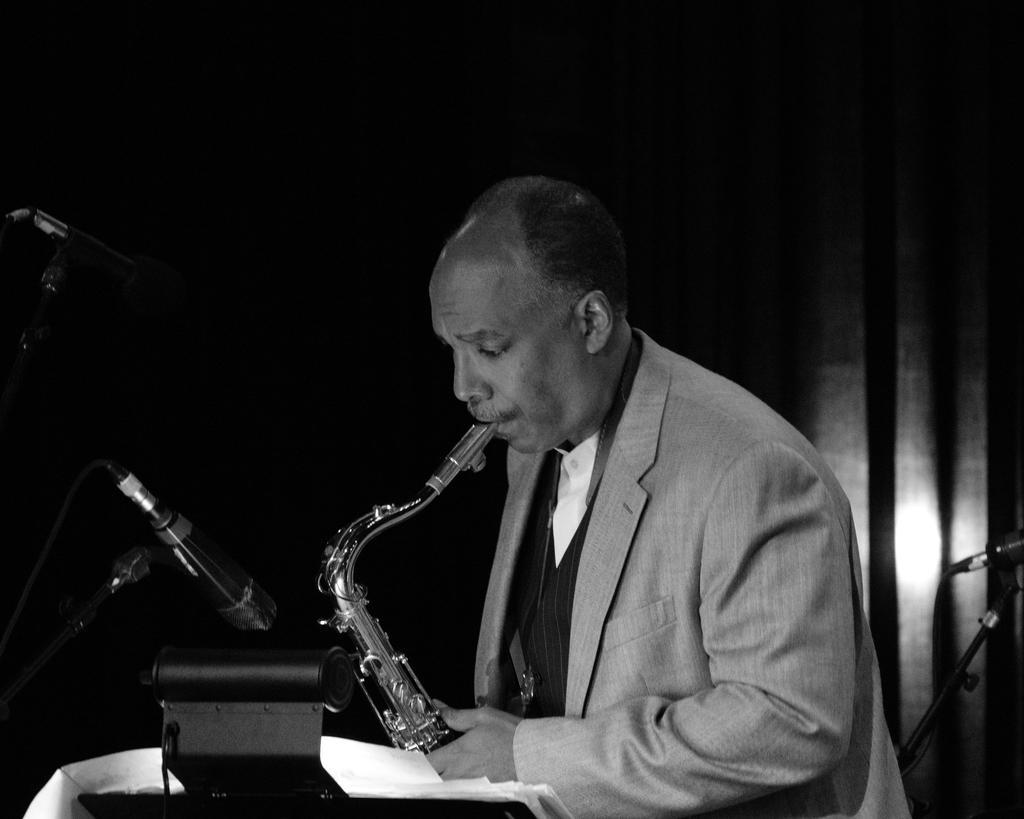Could you give a brief overview of what you see in this image? This is a black and white image. In the center of the image we can see man holding a saxophone. On the left side of the image we can see mice and stand. In the background there is a curtain. 